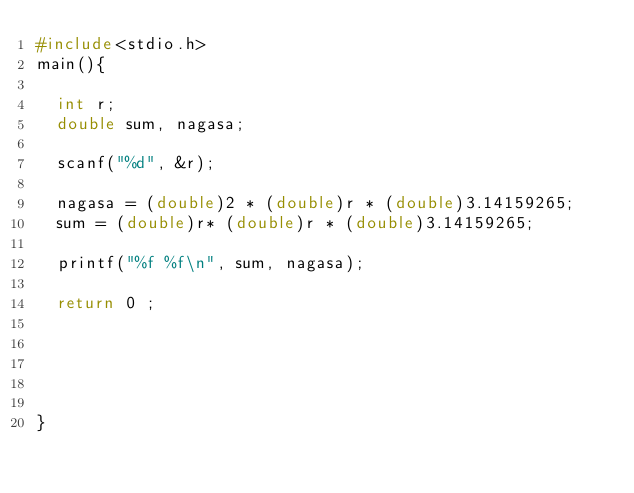<code> <loc_0><loc_0><loc_500><loc_500><_C_>#include<stdio.h>
main(){

  int r;
  double sum, nagasa;

  scanf("%d", &r);

  nagasa = (double)2 * (double)r * (double)3.14159265;
  sum = (double)r* (double)r * (double)3.14159265;

  printf("%f %f\n", sum, nagasa);

  return 0 ;





}</code> 